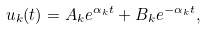<formula> <loc_0><loc_0><loc_500><loc_500>u _ { k } ( t ) = A _ { k } e ^ { \alpha _ { k } t } + B _ { k } e ^ { - \alpha _ { k } t } ,</formula> 